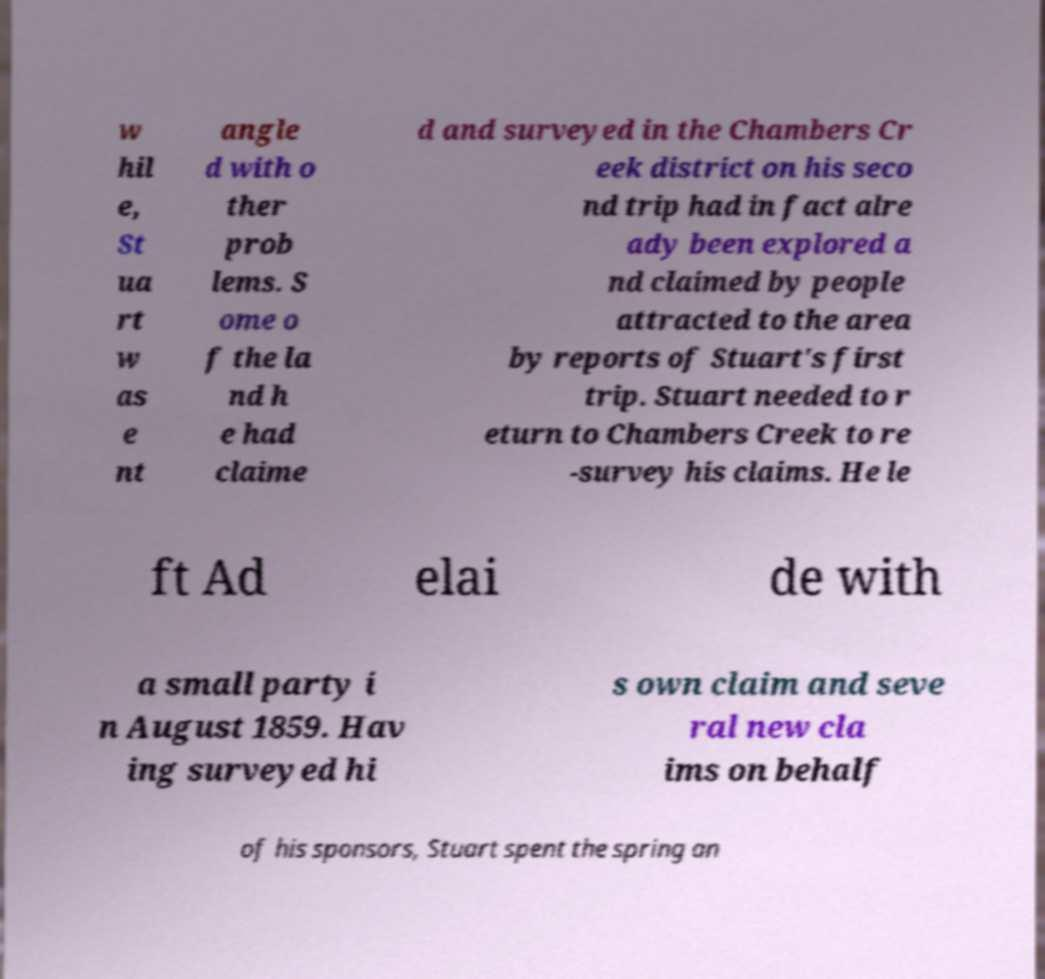Can you accurately transcribe the text from the provided image for me? w hil e, St ua rt w as e nt angle d with o ther prob lems. S ome o f the la nd h e had claime d and surveyed in the Chambers Cr eek district on his seco nd trip had in fact alre ady been explored a nd claimed by people attracted to the area by reports of Stuart's first trip. Stuart needed to r eturn to Chambers Creek to re -survey his claims. He le ft Ad elai de with a small party i n August 1859. Hav ing surveyed hi s own claim and seve ral new cla ims on behalf of his sponsors, Stuart spent the spring an 